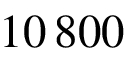<formula> <loc_0><loc_0><loc_500><loc_500>1 0 \, 8 0 0</formula> 